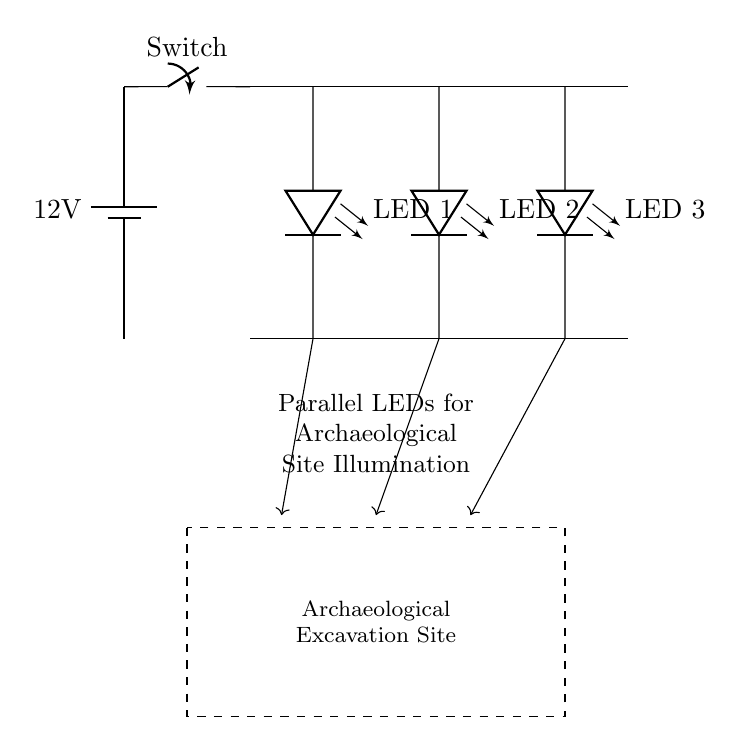What is the voltage of this circuit? The voltage is 12 volts, which is indicated by the battery symbol shown at the left side of the circuit diagram.
Answer: 12 volts What type of circuit is used for the LEDs? The circuit is a parallel circuit, demonstrated by the individual connections of each LED to the main wire, allowing each LED to receive the same voltage.
Answer: Parallel How many LEDs are in the circuit? There are three LEDs depicted in the circuit diagram, labeled as LED 1, LED 2, and LED 3.
Answer: Three What is the function of the switch in this circuit? The switch's role is to control the flow of current in the circuit by connecting or disconnecting the battery from the LEDs.
Answer: Control current What happens if one LED fails? If one LED fails, the other LEDs will continue to function since they are connected in parallel, maintaining the circuit's operation.
Answer: Remain lit What is the purpose of this lighting system? The purpose of the lighting system is to illuminate archaeological excavation sites to facilitate visibility and work during the excavation process.
Answer: Light excavation sites 